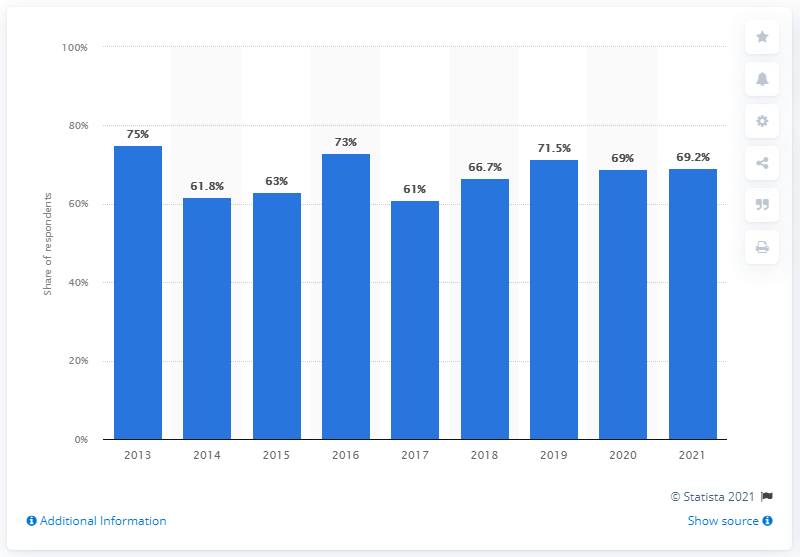Mention a couple of crucial points in this snapshot. In 2021, 69.2% of Italian respondents stated that they trust the State Police. 